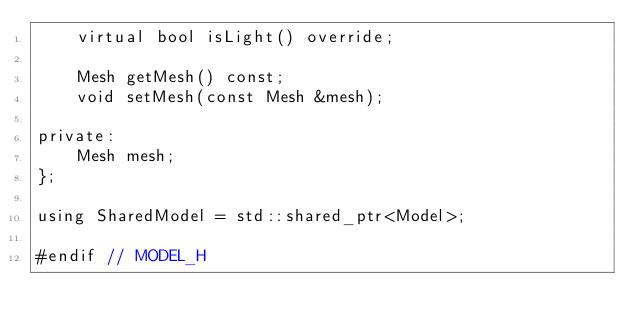Convert code to text. <code><loc_0><loc_0><loc_500><loc_500><_C_>    virtual bool isLight() override;

    Mesh getMesh() const;
    void setMesh(const Mesh &mesh);

private:
    Mesh mesh;
};

using SharedModel = std::shared_ptr<Model>;

#endif // MODEL_H
</code> 